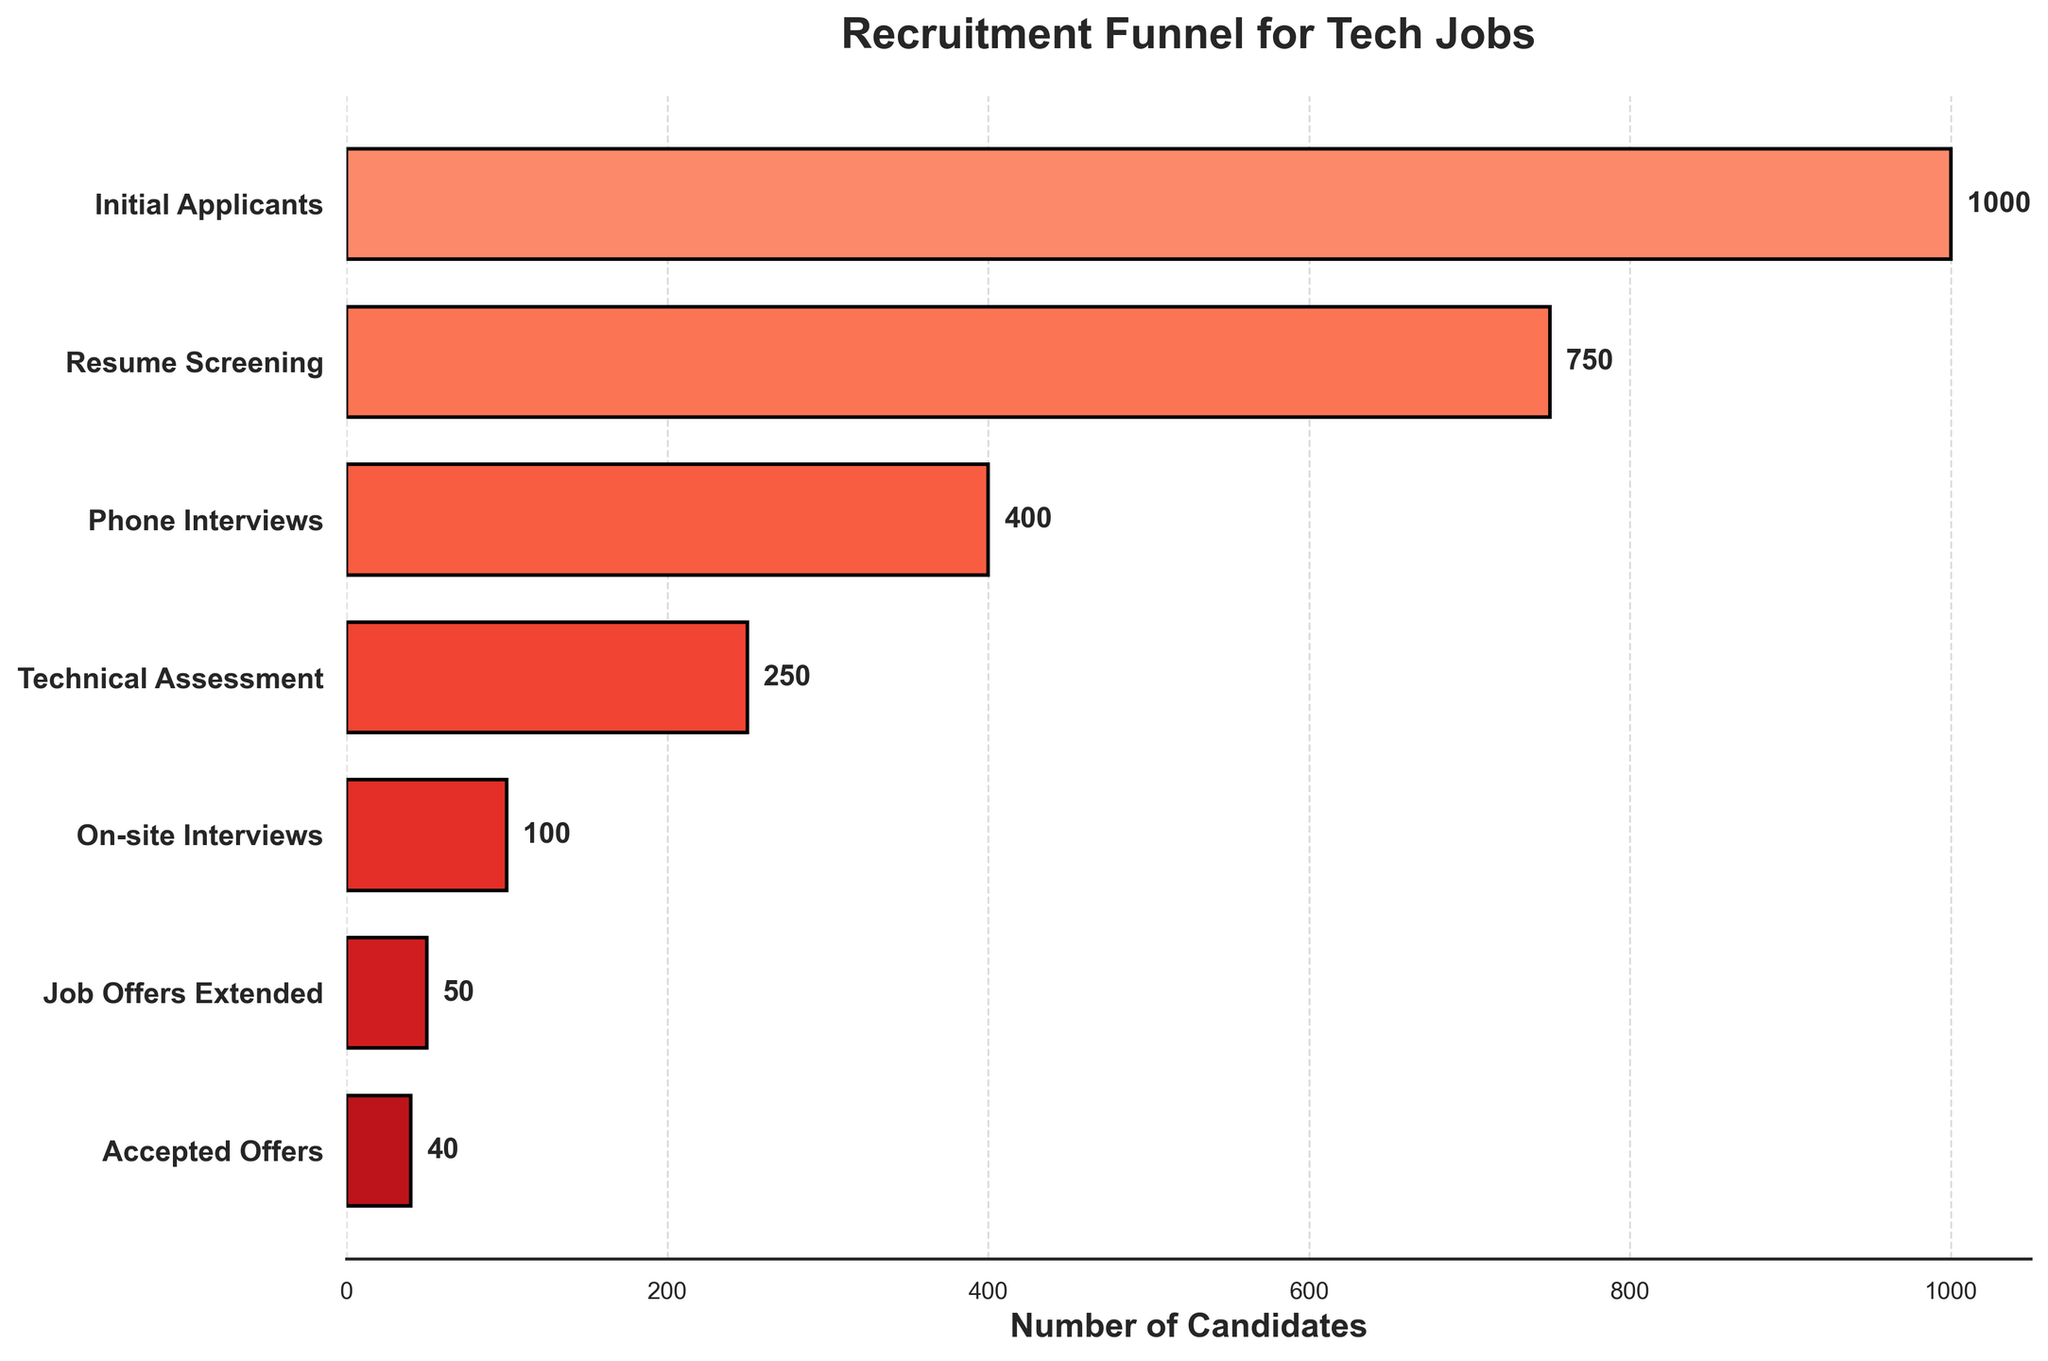What's the title of the chart? The title is positioned at the top of the chart, above the x- and y-axes.
Answer: Recruitment Funnel for Tech Jobs How many stages are there in the recruitment funnel? Count the number of unique stages labeled on the y-axis.
Answer: 7 Which stage has the highest number of candidates? Look for the bar with the greatest width and read its corresponding y-axis label.
Answer: Initial Applicants What's the difference in the number of candidates between the resume screening stage and the phone interviews stage? Subtract the number of candidates at the phone interviews stage from the number of candidates at the resume screening stage (750 - 400).
Answer: 350 What proportion of initial applicants move on to the technical assessment stage? Divide the number of candidates at the technical assessment stage by the number of initial applicants and multiply by 100 to get the percentage (250 / 1000 * 100).
Answer: 25% At which stage do we see the largest drop in the number of candidates? Compare the difference in the number of candidates between consecutive stages and identify the largest drop.
Answer: Resume Screening to Phone Interviews How many candidates received job offers but didn't accept them? Subtract the number of accepted offers from the number of job offers extended (50 - 40).
Answer: 10 What is the total number of candidates from the phone interviews stage to the accepted offers stage? Sum the number of candidates from the phone interviews stage onwards (400 + 250 + 100 + 50 + 40).
Answer: 840 Which stage has the second fewest number of candidates? Identify the second smallest bar on the chart and read its corresponding y-axis label.
Answer: Job Offers Extended Do more candidates get eliminated during resume screening or the technical assessment? Calculate the reduction in candidate numbers between initial applicants and resume screening, and between phone interviews and technical assessment, then compare (1000 - 750 = 250) vs (400 - 250 = 150).
Answer: Resume Screening 